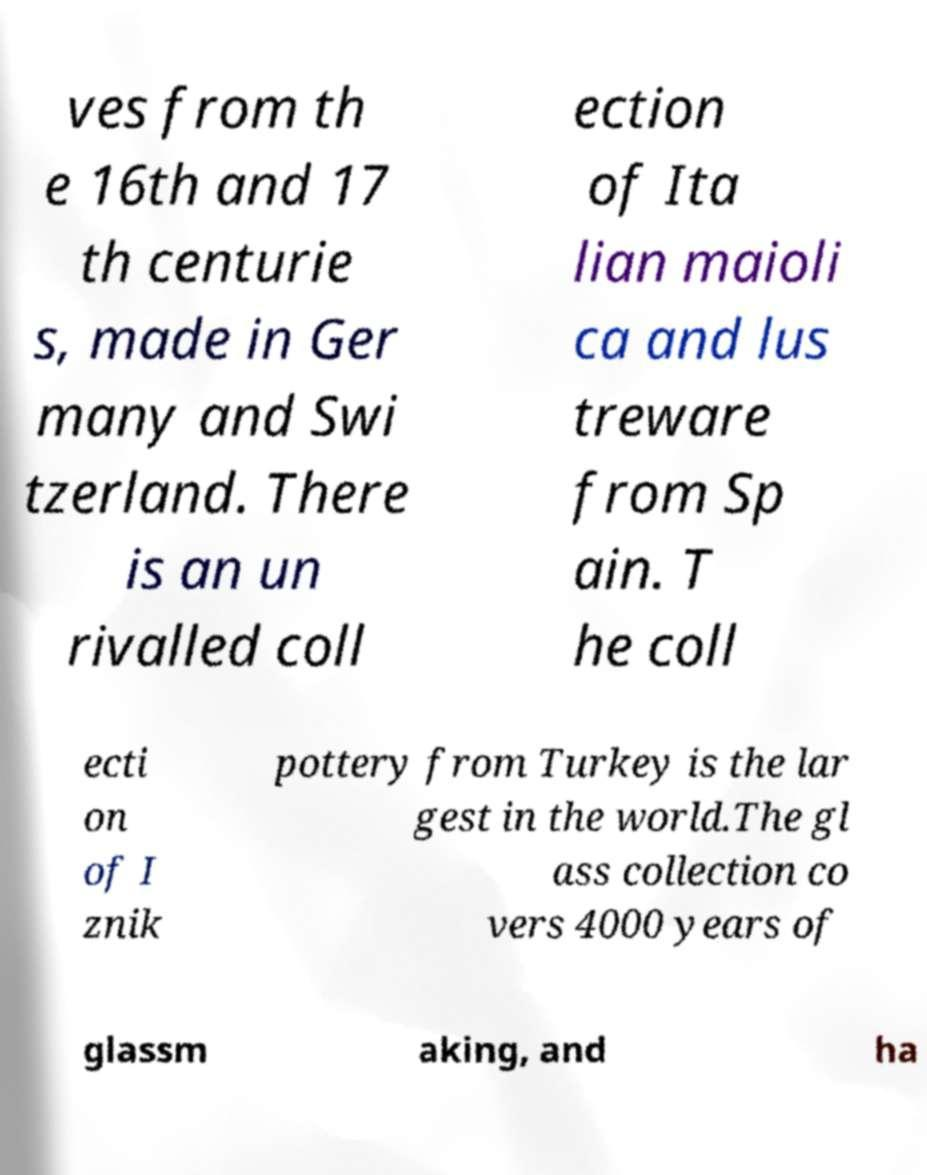Please read and relay the text visible in this image. What does it say? ves from th e 16th and 17 th centurie s, made in Ger many and Swi tzerland. There is an un rivalled coll ection of Ita lian maioli ca and lus treware from Sp ain. T he coll ecti on of I znik pottery from Turkey is the lar gest in the world.The gl ass collection co vers 4000 years of glassm aking, and ha 